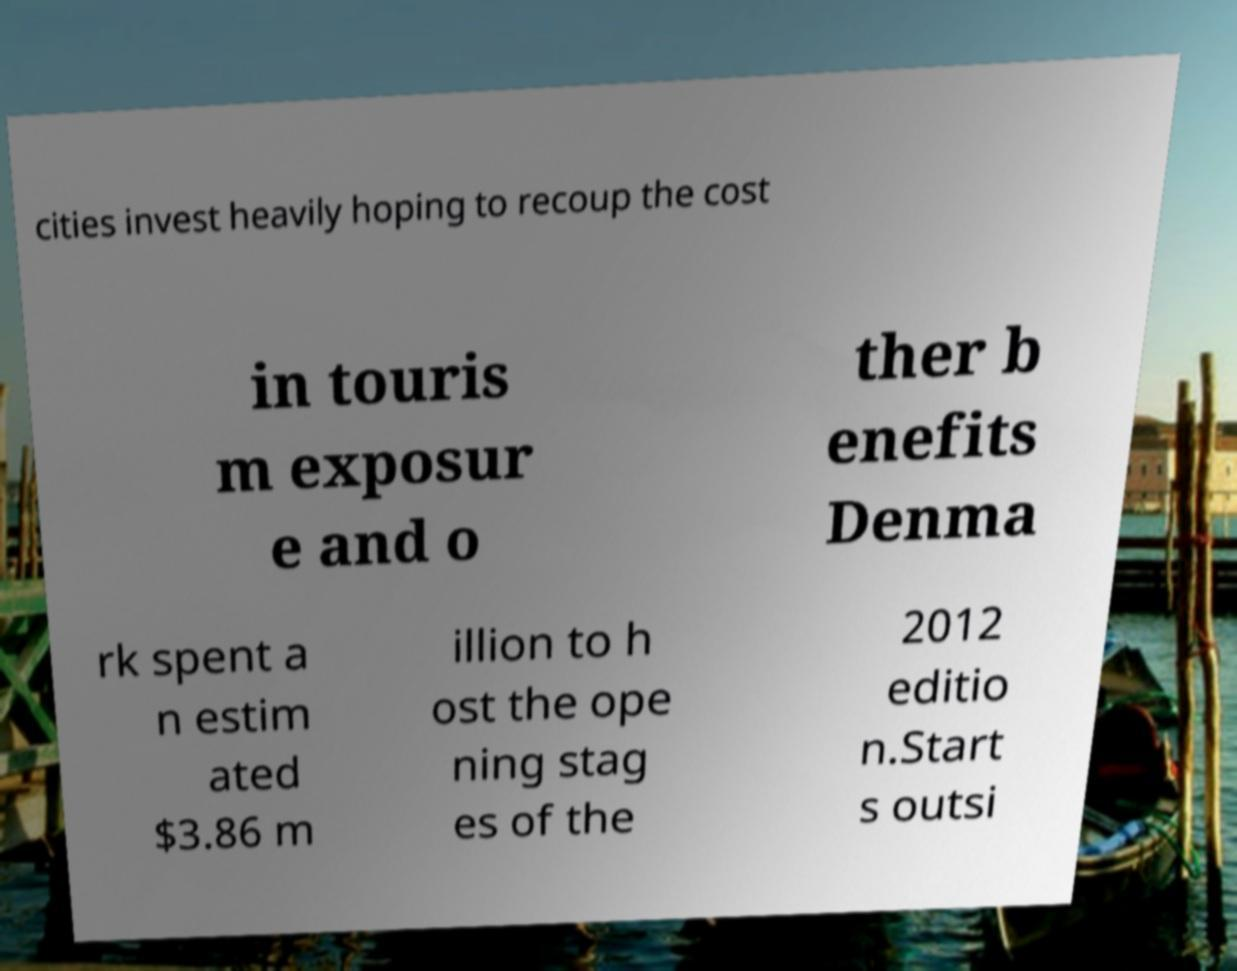Can you read and provide the text displayed in the image?This photo seems to have some interesting text. Can you extract and type it out for me? cities invest heavily hoping to recoup the cost in touris m exposur e and o ther b enefits Denma rk spent a n estim ated $3.86 m illion to h ost the ope ning stag es of the 2012 editio n.Start s outsi 